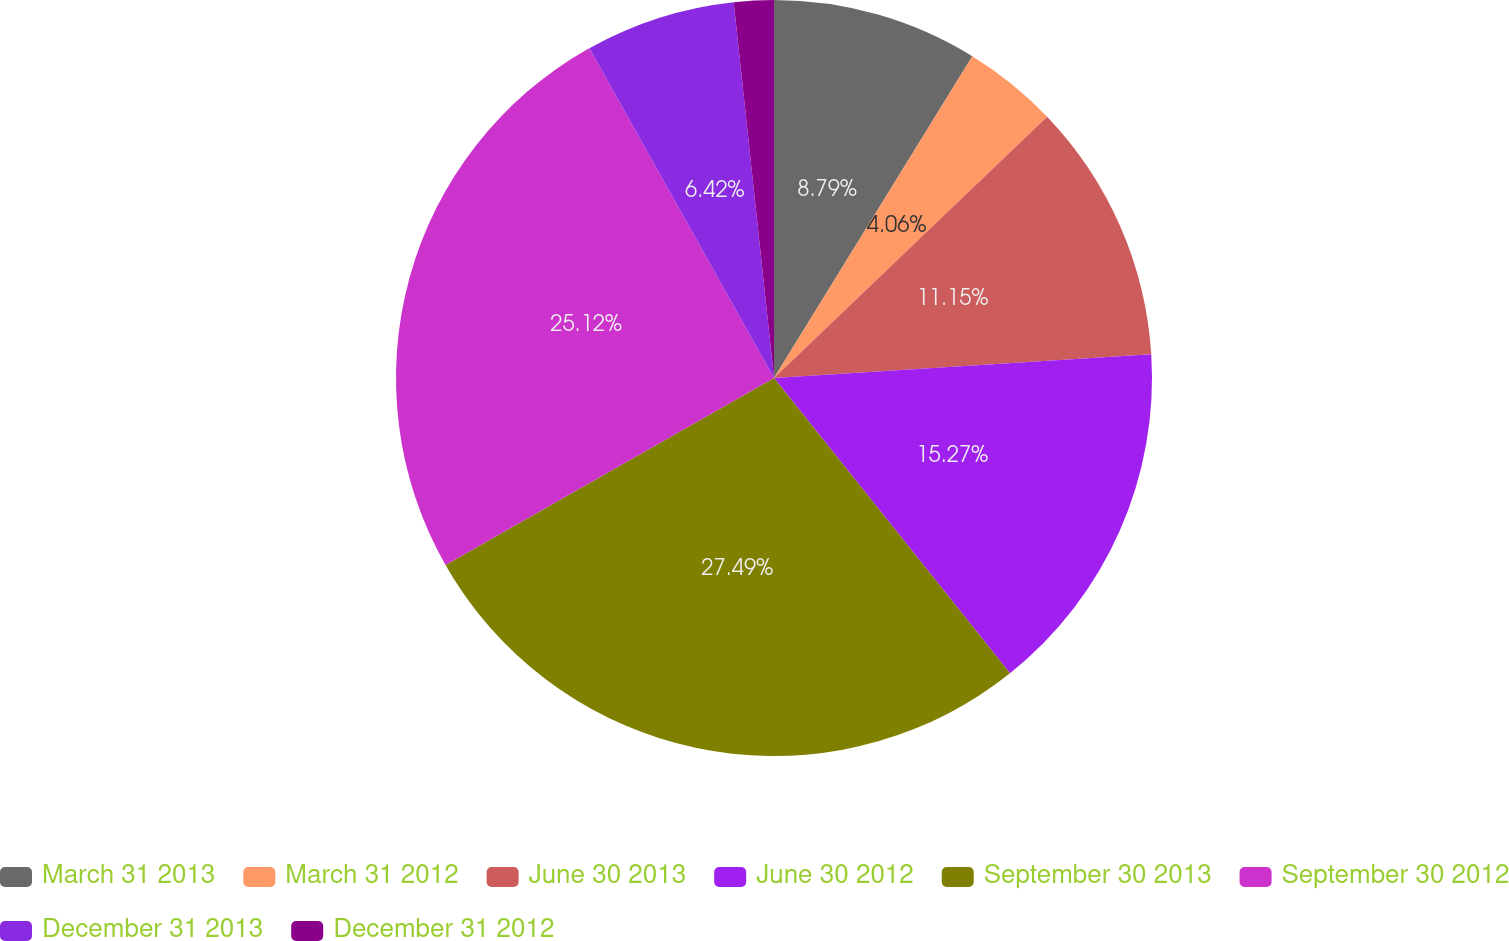<chart> <loc_0><loc_0><loc_500><loc_500><pie_chart><fcel>March 31 2013<fcel>March 31 2012<fcel>June 30 2013<fcel>June 30 2012<fcel>September 30 2013<fcel>September 30 2012<fcel>December 31 2013<fcel>December 31 2012<nl><fcel>8.79%<fcel>4.06%<fcel>11.15%<fcel>15.27%<fcel>27.49%<fcel>25.12%<fcel>6.42%<fcel>1.7%<nl></chart> 